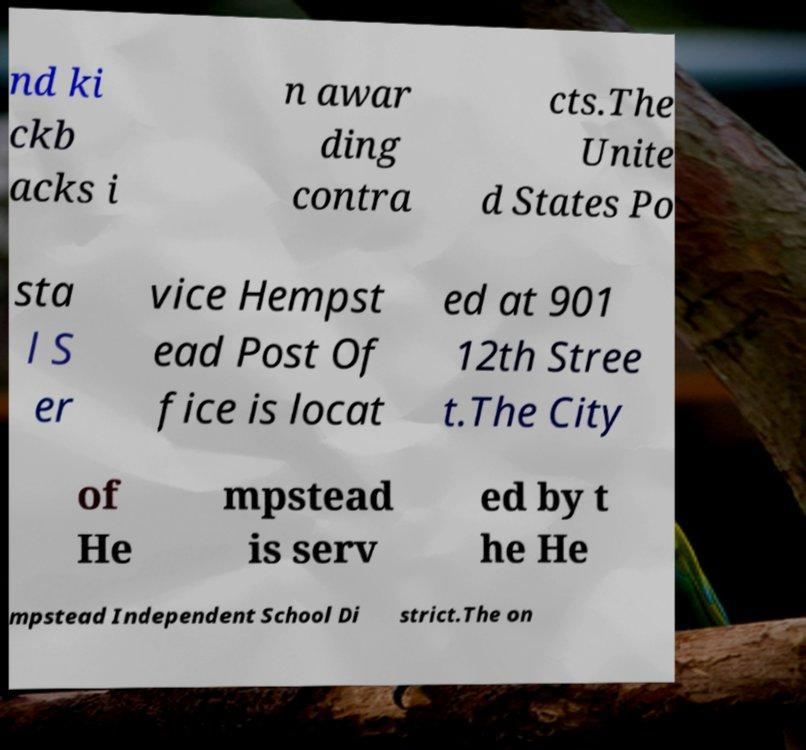Can you accurately transcribe the text from the provided image for me? nd ki ckb acks i n awar ding contra cts.The Unite d States Po sta l S er vice Hempst ead Post Of fice is locat ed at 901 12th Stree t.The City of He mpstead is serv ed by t he He mpstead Independent School Di strict.The on 